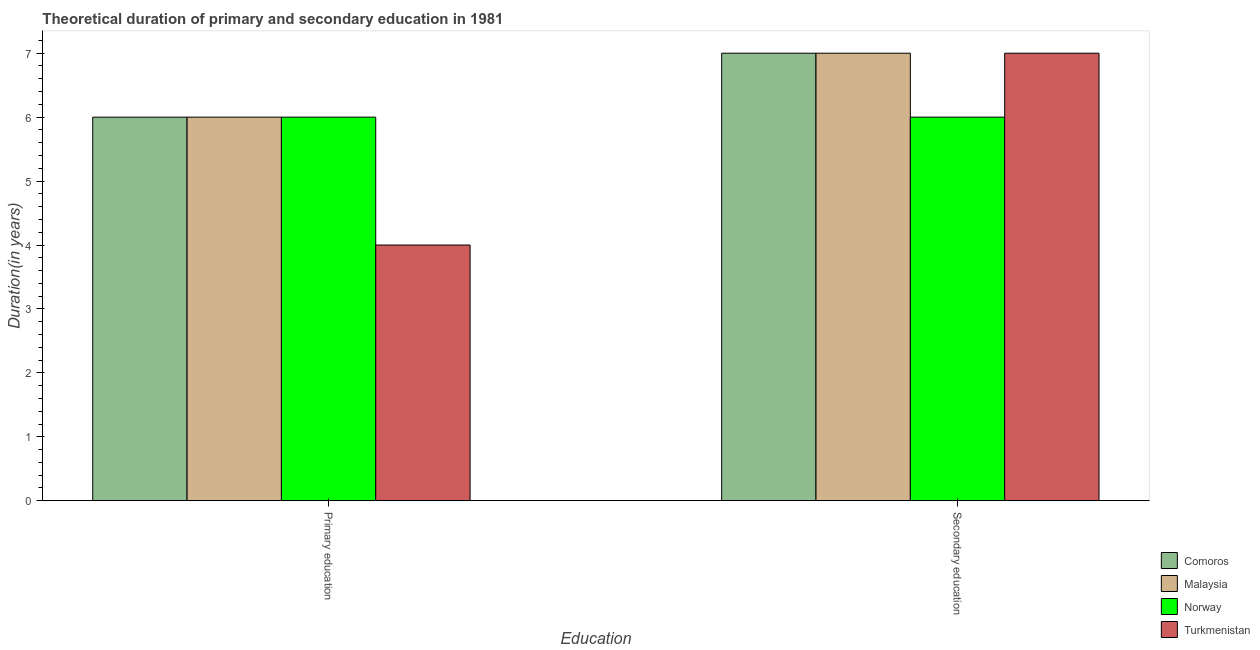How many different coloured bars are there?
Provide a short and direct response. 4. Are the number of bars per tick equal to the number of legend labels?
Offer a very short reply. Yes. How many bars are there on the 1st tick from the left?
Your answer should be compact. 4. What is the label of the 2nd group of bars from the left?
Offer a very short reply. Secondary education. What is the duration of primary education in Norway?
Give a very brief answer. 6. Across all countries, what is the maximum duration of primary education?
Provide a short and direct response. 6. Across all countries, what is the minimum duration of primary education?
Offer a very short reply. 4. In which country was the duration of secondary education maximum?
Offer a very short reply. Comoros. What is the total duration of primary education in the graph?
Keep it short and to the point. 22. What is the difference between the duration of secondary education in Turkmenistan and the duration of primary education in Comoros?
Your answer should be compact. 1. What is the average duration of primary education per country?
Provide a short and direct response. 5.5. What is the difference between the duration of primary education and duration of secondary education in Turkmenistan?
Offer a terse response. -3. What is the ratio of the duration of primary education in Norway to that in Turkmenistan?
Your answer should be compact. 1.5. Is the duration of secondary education in Comoros less than that in Norway?
Give a very brief answer. No. In how many countries, is the duration of secondary education greater than the average duration of secondary education taken over all countries?
Offer a terse response. 3. What does the 2nd bar from the left in Secondary education represents?
Give a very brief answer. Malaysia. What does the 4th bar from the right in Secondary education represents?
Offer a very short reply. Comoros. How many bars are there?
Keep it short and to the point. 8. Are the values on the major ticks of Y-axis written in scientific E-notation?
Give a very brief answer. No. Does the graph contain grids?
Provide a short and direct response. No. Where does the legend appear in the graph?
Ensure brevity in your answer.  Bottom right. How are the legend labels stacked?
Provide a succinct answer. Vertical. What is the title of the graph?
Offer a very short reply. Theoretical duration of primary and secondary education in 1981. What is the label or title of the X-axis?
Give a very brief answer. Education. What is the label or title of the Y-axis?
Your response must be concise. Duration(in years). What is the Duration(in years) in Comoros in Primary education?
Give a very brief answer. 6. What is the Duration(in years) in Malaysia in Primary education?
Ensure brevity in your answer.  6. What is the Duration(in years) in Norway in Primary education?
Your answer should be compact. 6. What is the Duration(in years) of Turkmenistan in Primary education?
Offer a very short reply. 4. What is the Duration(in years) of Malaysia in Secondary education?
Your answer should be compact. 7. What is the Duration(in years) in Norway in Secondary education?
Your answer should be compact. 6. What is the Duration(in years) of Turkmenistan in Secondary education?
Give a very brief answer. 7. Across all Education, what is the maximum Duration(in years) of Malaysia?
Ensure brevity in your answer.  7. Across all Education, what is the maximum Duration(in years) in Turkmenistan?
Keep it short and to the point. 7. Across all Education, what is the minimum Duration(in years) of Comoros?
Your response must be concise. 6. Across all Education, what is the minimum Duration(in years) in Malaysia?
Provide a short and direct response. 6. Across all Education, what is the minimum Duration(in years) in Norway?
Give a very brief answer. 6. Across all Education, what is the minimum Duration(in years) of Turkmenistan?
Provide a succinct answer. 4. What is the total Duration(in years) in Turkmenistan in the graph?
Offer a very short reply. 11. What is the difference between the Duration(in years) of Malaysia in Primary education and that in Secondary education?
Ensure brevity in your answer.  -1. What is the difference between the Duration(in years) in Norway in Primary education and that in Secondary education?
Offer a very short reply. 0. What is the difference between the Duration(in years) in Turkmenistan in Primary education and that in Secondary education?
Offer a very short reply. -3. What is the difference between the Duration(in years) in Comoros in Primary education and the Duration(in years) in Malaysia in Secondary education?
Your answer should be very brief. -1. What is the difference between the Duration(in years) of Comoros in Primary education and the Duration(in years) of Norway in Secondary education?
Offer a very short reply. 0. What is the difference between the Duration(in years) of Comoros in Primary education and the Duration(in years) of Turkmenistan in Secondary education?
Offer a terse response. -1. What is the average Duration(in years) of Comoros per Education?
Give a very brief answer. 6.5. What is the average Duration(in years) in Malaysia per Education?
Ensure brevity in your answer.  6.5. What is the average Duration(in years) in Norway per Education?
Provide a succinct answer. 6. What is the average Duration(in years) of Turkmenistan per Education?
Your answer should be compact. 5.5. What is the difference between the Duration(in years) in Comoros and Duration(in years) in Malaysia in Primary education?
Offer a very short reply. 0. What is the difference between the Duration(in years) in Malaysia and Duration(in years) in Norway in Primary education?
Offer a very short reply. 0. What is the difference between the Duration(in years) of Norway and Duration(in years) of Turkmenistan in Primary education?
Offer a terse response. 2. What is the difference between the Duration(in years) in Comoros and Duration(in years) in Malaysia in Secondary education?
Provide a succinct answer. 0. What is the difference between the Duration(in years) in Comoros and Duration(in years) in Turkmenistan in Secondary education?
Your answer should be very brief. 0. What is the difference between the Duration(in years) in Malaysia and Duration(in years) in Turkmenistan in Secondary education?
Make the answer very short. 0. What is the difference between the Duration(in years) of Norway and Duration(in years) of Turkmenistan in Secondary education?
Provide a short and direct response. -1. What is the difference between the highest and the second highest Duration(in years) of Comoros?
Your answer should be very brief. 1. What is the difference between the highest and the second highest Duration(in years) in Malaysia?
Keep it short and to the point. 1. What is the difference between the highest and the second highest Duration(in years) of Norway?
Give a very brief answer. 0. What is the difference between the highest and the second highest Duration(in years) in Turkmenistan?
Make the answer very short. 3. What is the difference between the highest and the lowest Duration(in years) of Malaysia?
Provide a succinct answer. 1. What is the difference between the highest and the lowest Duration(in years) in Turkmenistan?
Your answer should be very brief. 3. 